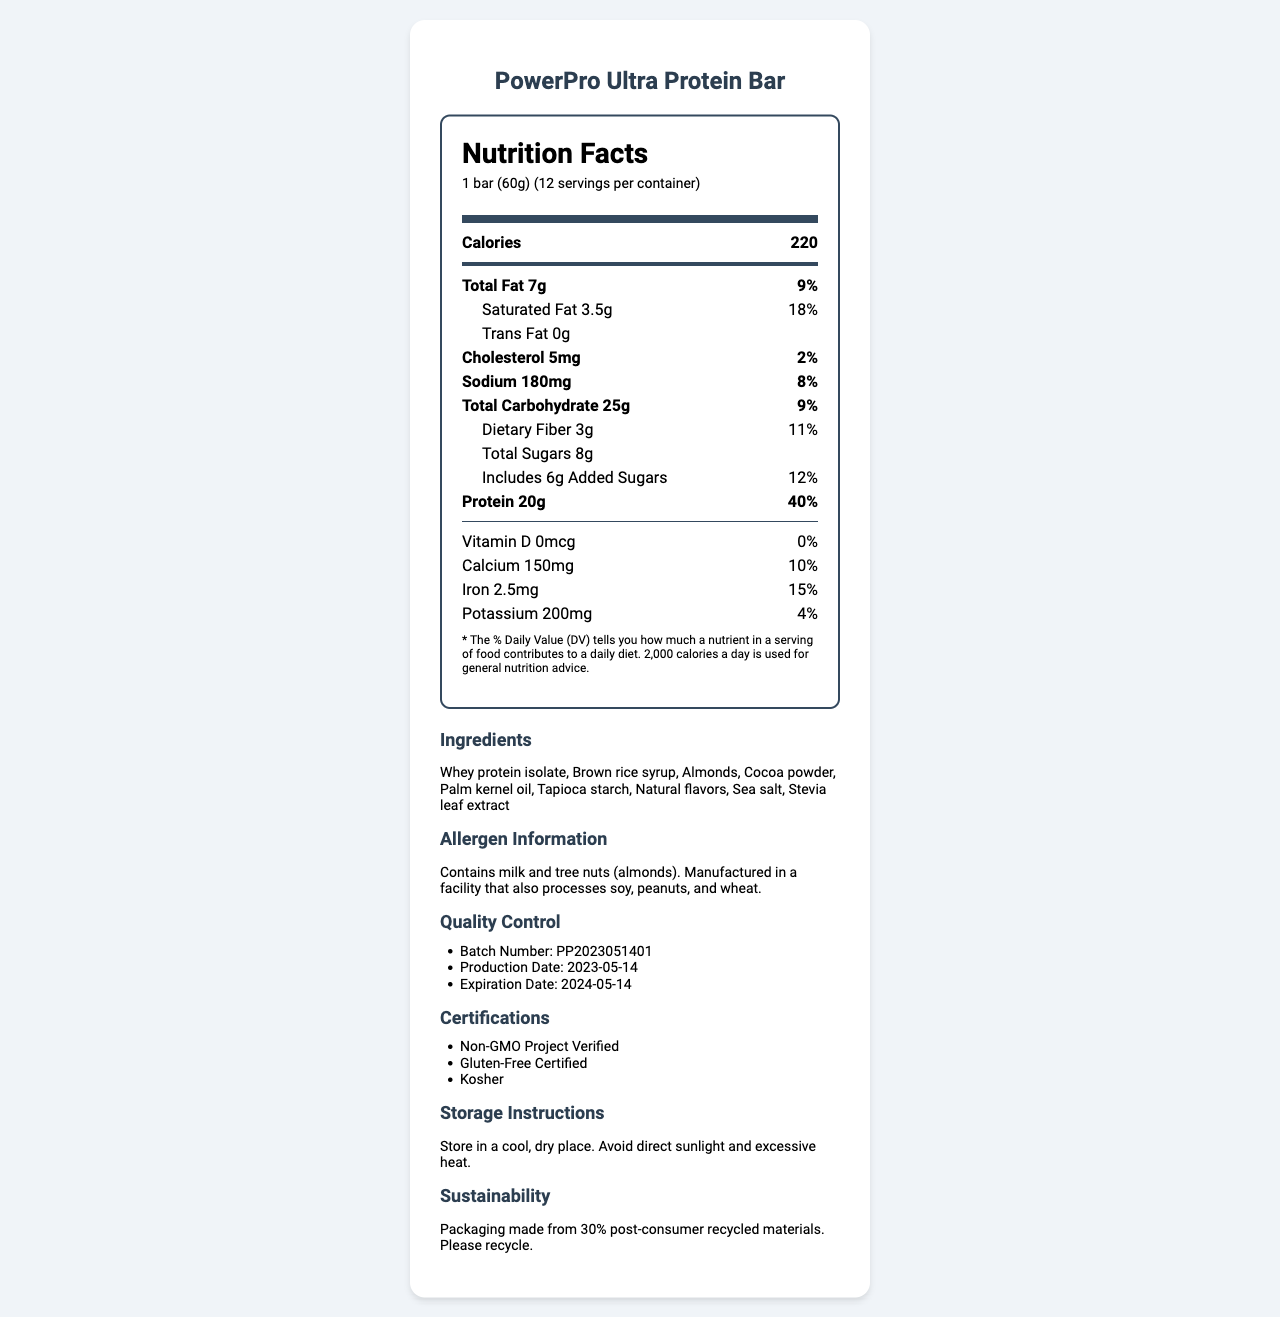what is the serving size of the protein bar? The serving size is clearly stated at the beginning of the document.
Answer: 1 bar (60g) how many calories are in one serving? The number of calories per serving is mentioned directly under the product name in the nutrition label.
Answer: 220 what is the amount of saturated fat in one serving? The amount of saturated fat is listed under the Total Fat section.
Answer: 3.5g how much protein does one bar contain? The protein content is provided prominently in the nutrition label.
Answer: 20g what are the three certifications mentioned in the document? The certifications are listed in a bulleted format in the additional information section of the document.
Answer: Non-GMO Project Verified, Gluten-Free Certified, Kosher what is the batch number for this product? A. PP2023051401 B. PP2023061502 C. PP2023071603 D. PP2023081704 The batch number is listed under the Quality Control section in the additional information area.
Answer: A which of the following ingredients is not in the protein bar? I. Whey protein isolate II. Almonds III. Soy protein IV. Palm kernel oil The list of ingredients includes Whey protein isolate, Almonds, and Palm kernel oil, but does not include Soy protein.
Answer: III. Soy protein is the product suitable for someone with a peanut allergy? The document mentions that it is manufactured in a facility that also processes peanuts.
Answer: No does this product contain any vitamin D? The nutrition label explicitly states that the amount of Vitamin D is 0mcg and the daily value is 0%.
Answer: No summarize the key nutritional information and additional details from the document. The summary captures the main nutritional aspects and additional considerations such as certifications, allergens, and sustainability efforts described in the document.
Answer: The PowerPro Ultra Protein Bar has 220 calories per serving, with detailed breakdowns of fats, carbohydrates, and proteins. It includes 7g of total fat, 25g of total carbohydrates, and 20g of protein. The bar contains 3.5g of saturated fat and 180mg of sodium. It is rich in protein with essential amino acids listed. The product has certifications like Non-GMO, Gluten-Free, and Kosher, and is packaged with post-consumer recycled materials. Allergen information and storage instructions are also provided. what is the daily value percentage of iron in one bar? The daily value percentage of iron is found in the section detailing vitamins and minerals.
Answer: 15% how many grams of dietary fiber are included in a single serving? The amount of dietary fiber is listed under the Total Carbohydrate section.
Answer: 3g is there any added sugar in the bar? The label indicates that there are 6g of added sugars.
Answer: Yes how long is the product shelf life from the production date? The production and expiration dates show a one-year difference, indicating the shelf life.
Answer: 1 year who is the manufacturer of the protein bar? The document does not provide information about the manufacturer.
Answer: Cannot be determined 